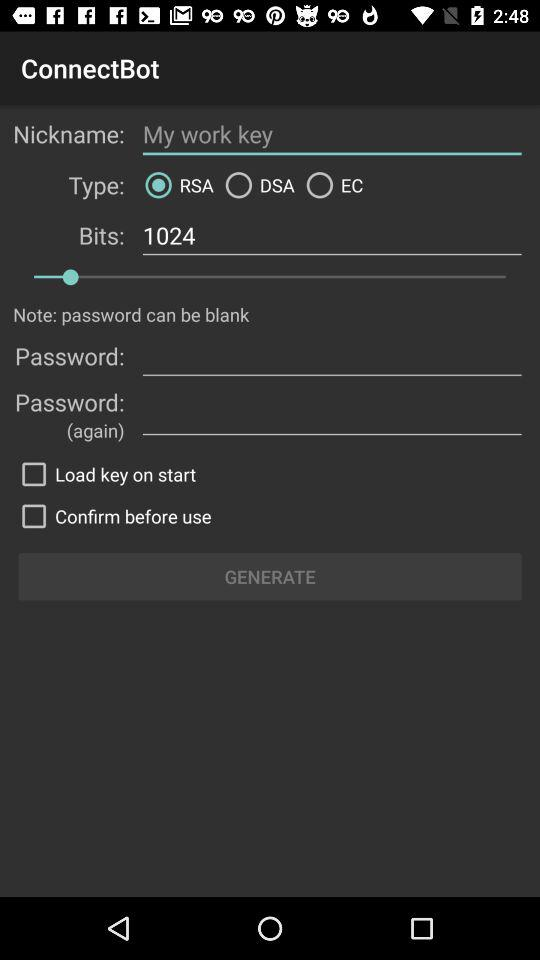What is the selected "Type"? The selected "Type" is "RSA". 